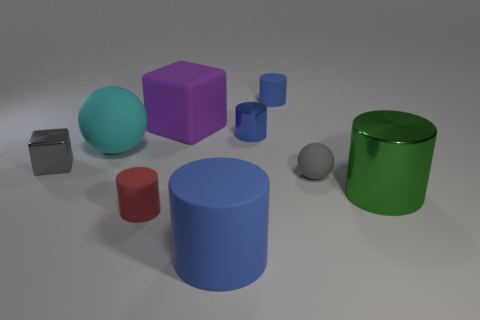Subtract all blue cylinders. How many were subtracted if there are1blue cylinders left? 2 Subtract all blue cubes. How many blue cylinders are left? 3 Subtract all big rubber cylinders. How many cylinders are left? 4 Subtract all green cylinders. How many cylinders are left? 4 Subtract all yellow cylinders. Subtract all gray cubes. How many cylinders are left? 5 Add 1 cyan objects. How many objects exist? 10 Subtract all cylinders. How many objects are left? 4 Subtract all small brown things. Subtract all cyan matte objects. How many objects are left? 8 Add 6 purple rubber blocks. How many purple rubber blocks are left? 7 Add 8 tiny metal balls. How many tiny metal balls exist? 8 